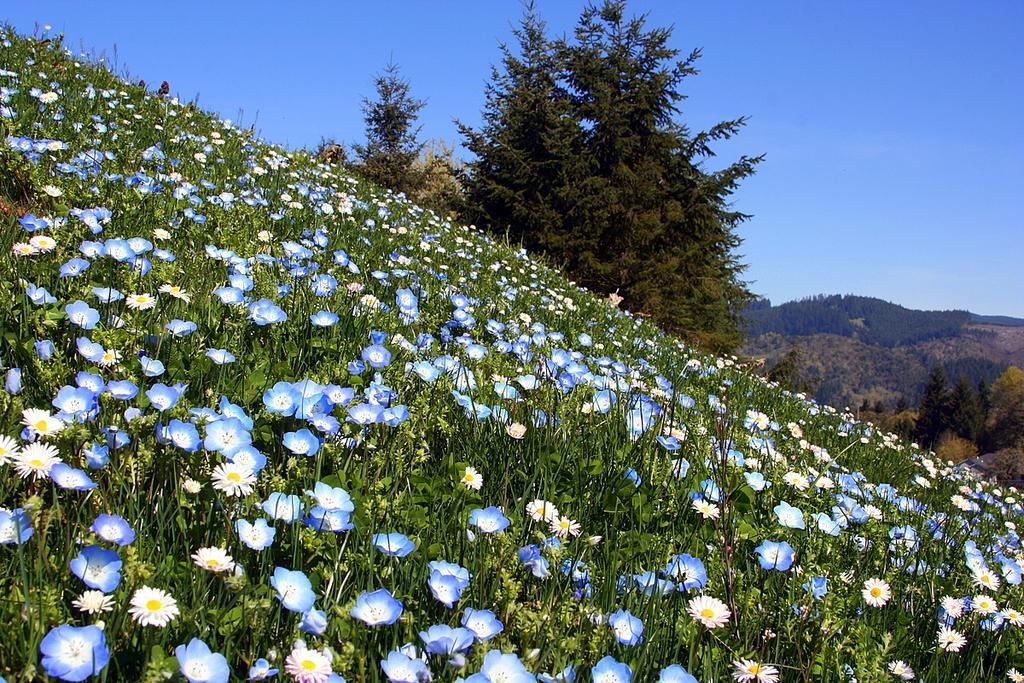Could you give a brief overview of what you see in this image? In this image I can see few trees and flowers in white, yellow and blue color. The sky is in blue color. 